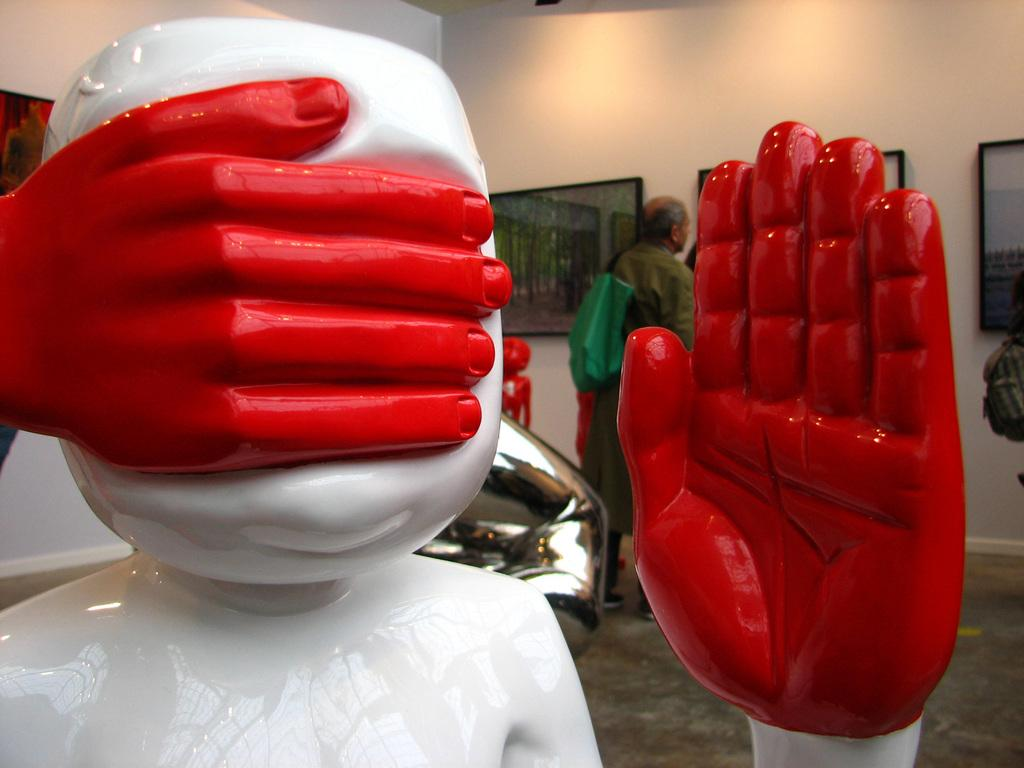What is the main subject in the front of the image? There is a statue in the front of the image. What can be seen in the background of the image? There are pictures on the wall and a person in the background of the image. Can you describe the pictures on the wall? The pictures are in the background of the image, and they are on the wall. What else is visible in the background of the image? There are walls and objects visible in the background of the image. What type of ink is being used by the robin in the image? There is no robin present in the image, so it is not possible to determine what type of ink it might be using. 